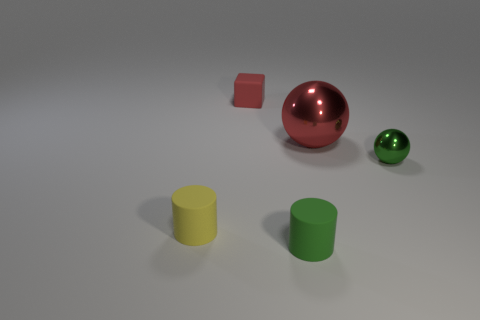Add 1 big red spheres. How many objects exist? 6 Subtract all cylinders. How many objects are left? 3 Subtract all tiny red rubber cylinders. Subtract all small green cylinders. How many objects are left? 4 Add 3 tiny green cylinders. How many tiny green cylinders are left? 4 Add 3 small blocks. How many small blocks exist? 4 Subtract 0 blue cylinders. How many objects are left? 5 